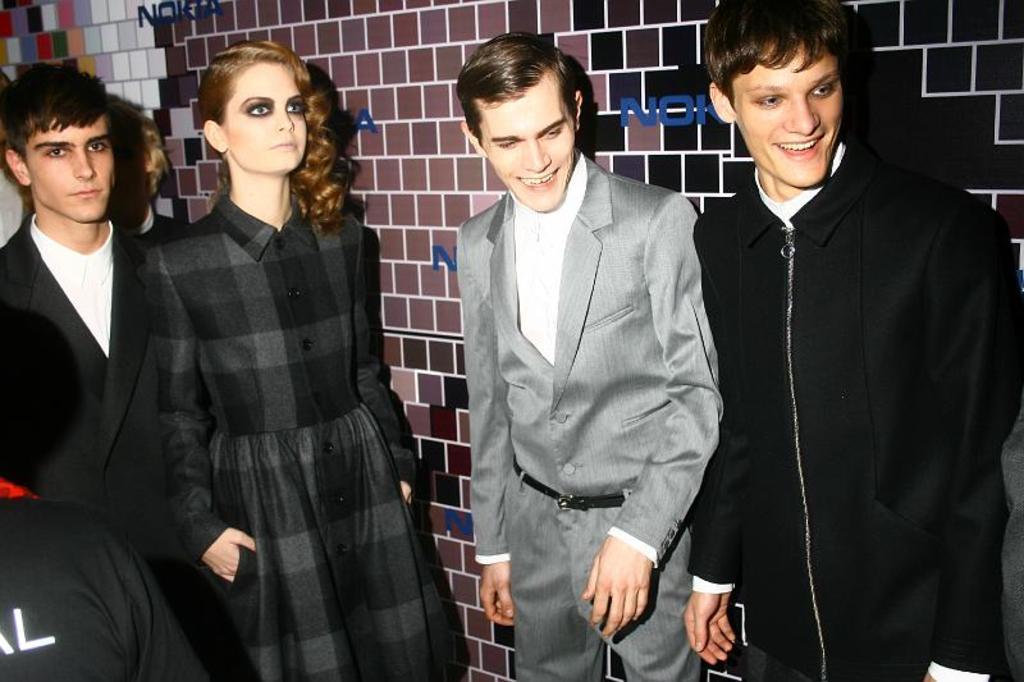Could you give a brief overview of what you see in this image? In this image we can see a group of people standing. One woman is wearing black dress. One person is wearing a grey coat with black belt. In the background, we can see wall on which text is present. 